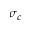Convert formula to latex. <formula><loc_0><loc_0><loc_500><loc_500>\sigma _ { c }</formula> 